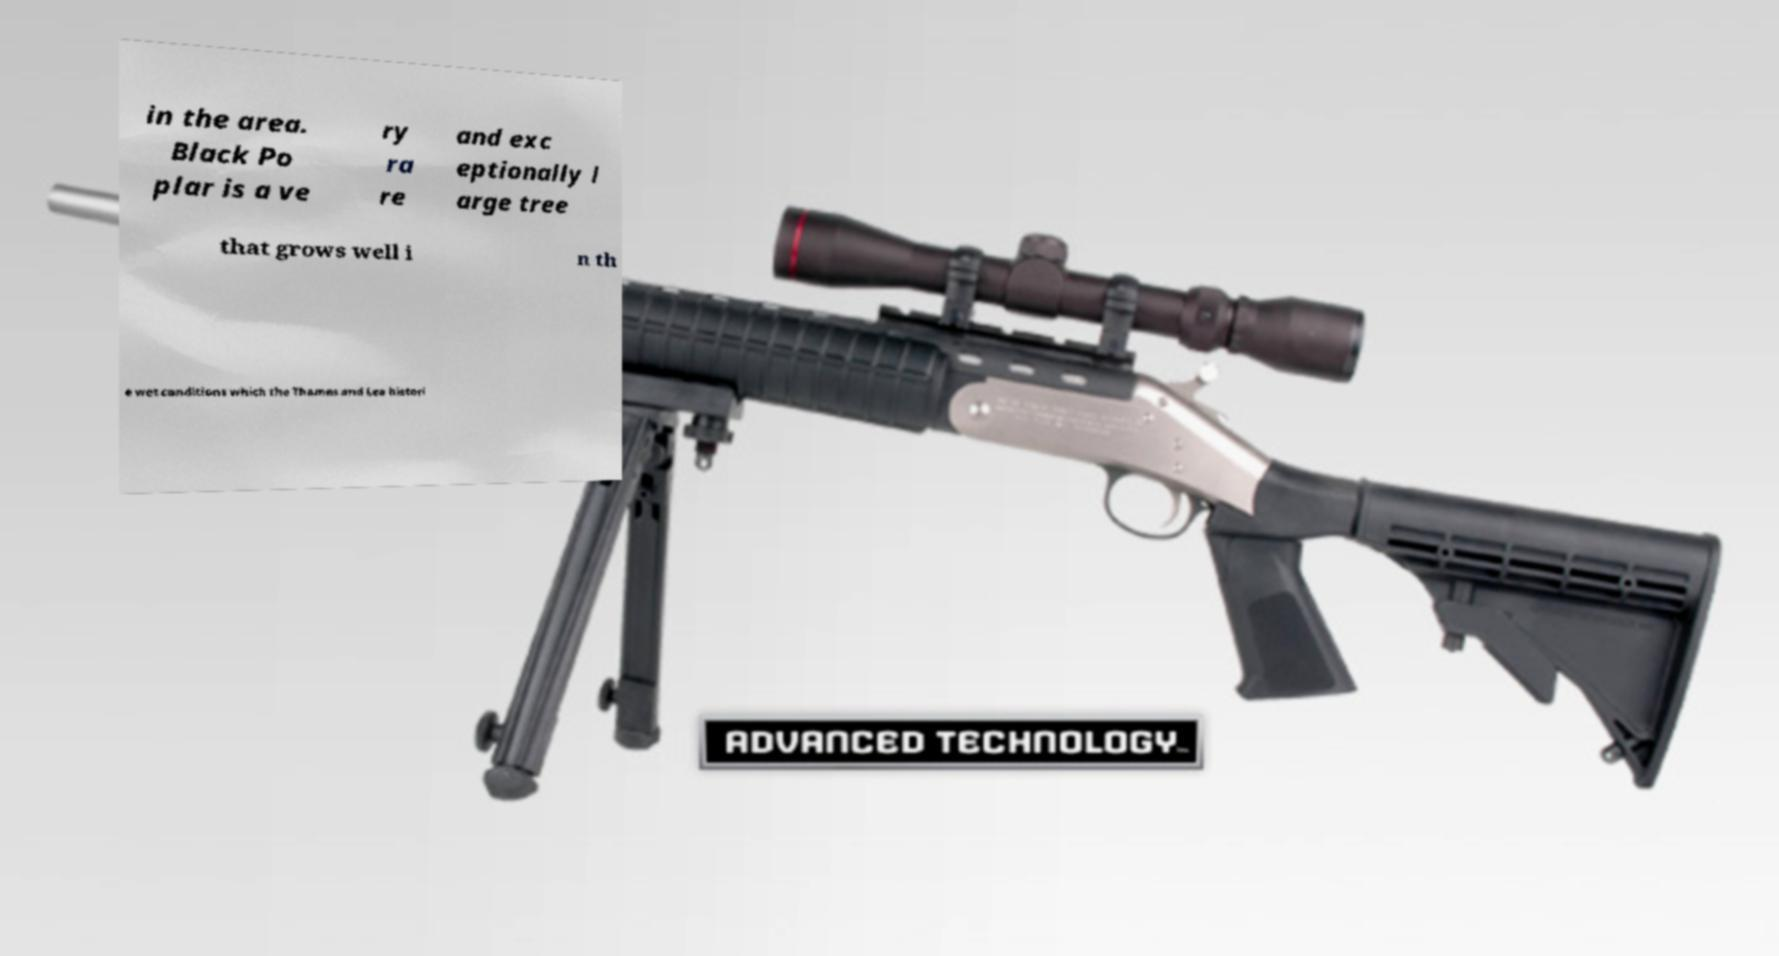Can you accurately transcribe the text from the provided image for me? in the area. Black Po plar is a ve ry ra re and exc eptionally l arge tree that grows well i n th e wet conditions which the Thames and Lea histori 